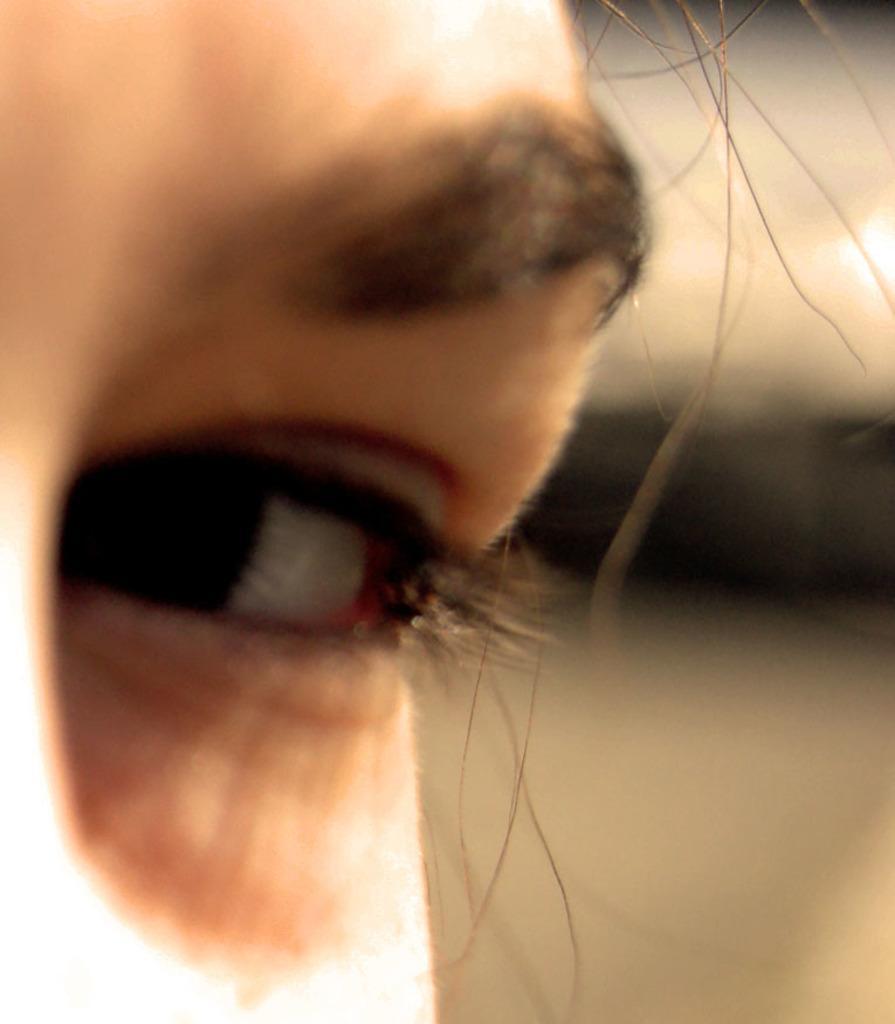Can you describe this image briefly? In this image I see a human face and I see the eyes and eyebrows and I see it is blurred in the background. 